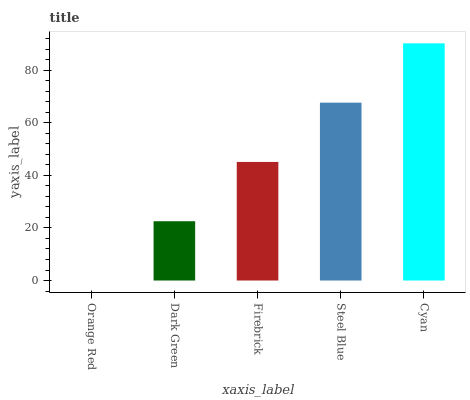Is Orange Red the minimum?
Answer yes or no. Yes. Is Cyan the maximum?
Answer yes or no. Yes. Is Dark Green the minimum?
Answer yes or no. No. Is Dark Green the maximum?
Answer yes or no. No. Is Dark Green greater than Orange Red?
Answer yes or no. Yes. Is Orange Red less than Dark Green?
Answer yes or no. Yes. Is Orange Red greater than Dark Green?
Answer yes or no. No. Is Dark Green less than Orange Red?
Answer yes or no. No. Is Firebrick the high median?
Answer yes or no. Yes. Is Firebrick the low median?
Answer yes or no. Yes. Is Dark Green the high median?
Answer yes or no. No. Is Orange Red the low median?
Answer yes or no. No. 